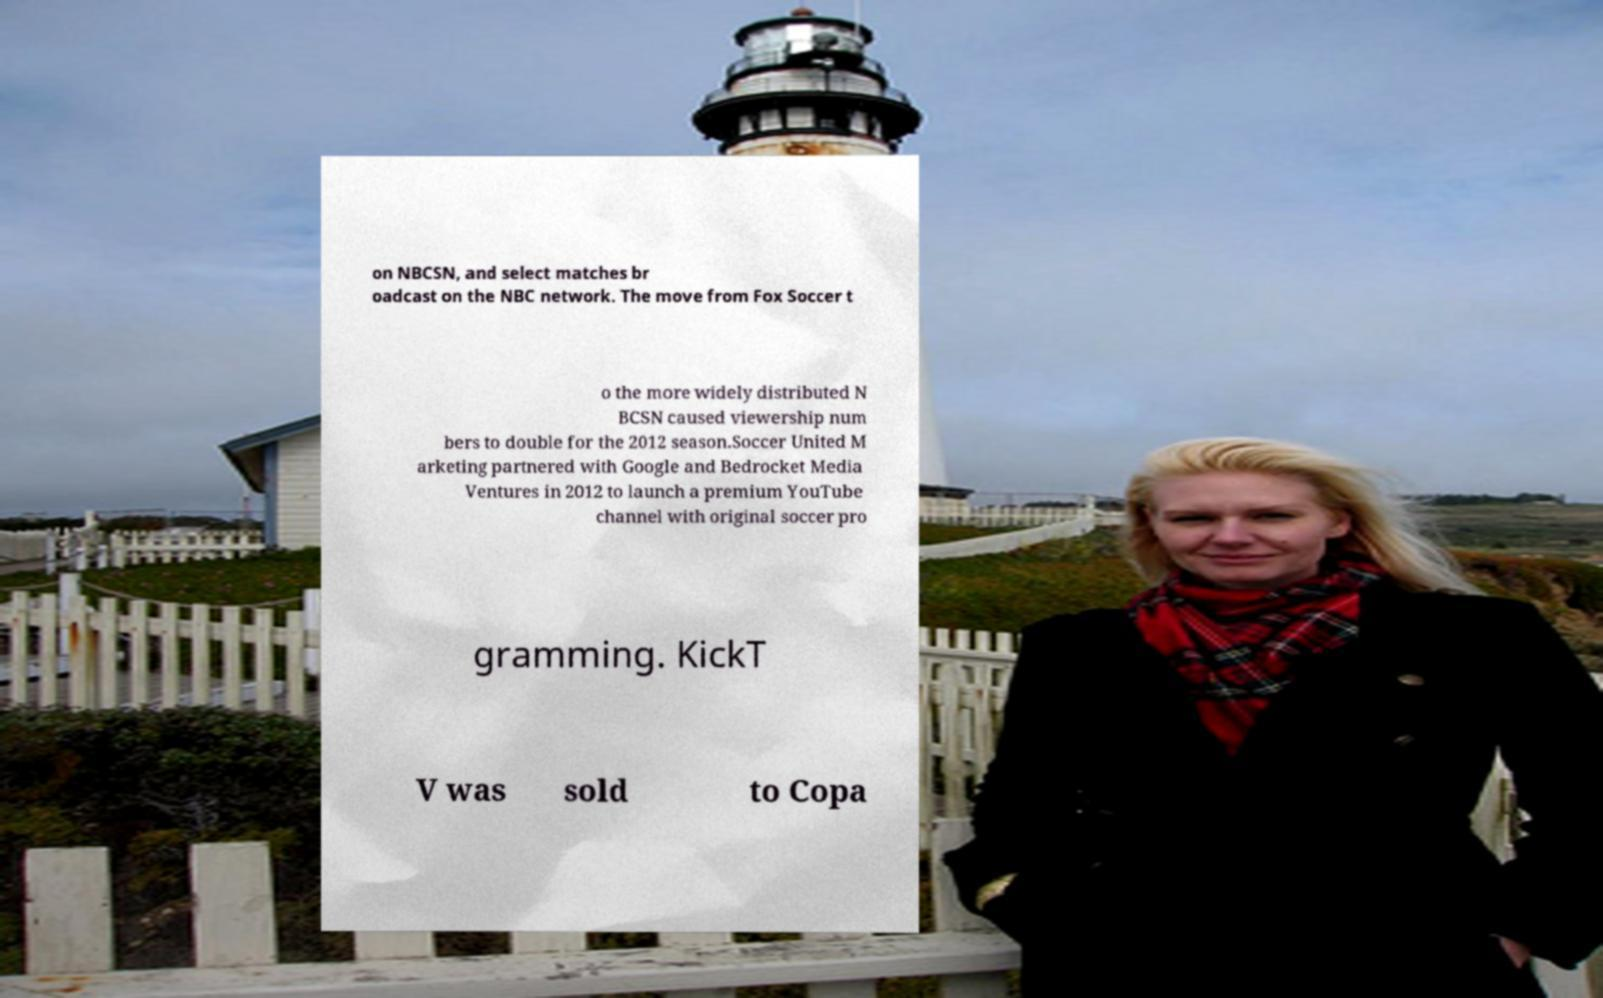There's text embedded in this image that I need extracted. Can you transcribe it verbatim? on NBCSN, and select matches br oadcast on the NBC network. The move from Fox Soccer t o the more widely distributed N BCSN caused viewership num bers to double for the 2012 season.Soccer United M arketing partnered with Google and Bedrocket Media Ventures in 2012 to launch a premium YouTube channel with original soccer pro gramming. KickT V was sold to Copa 